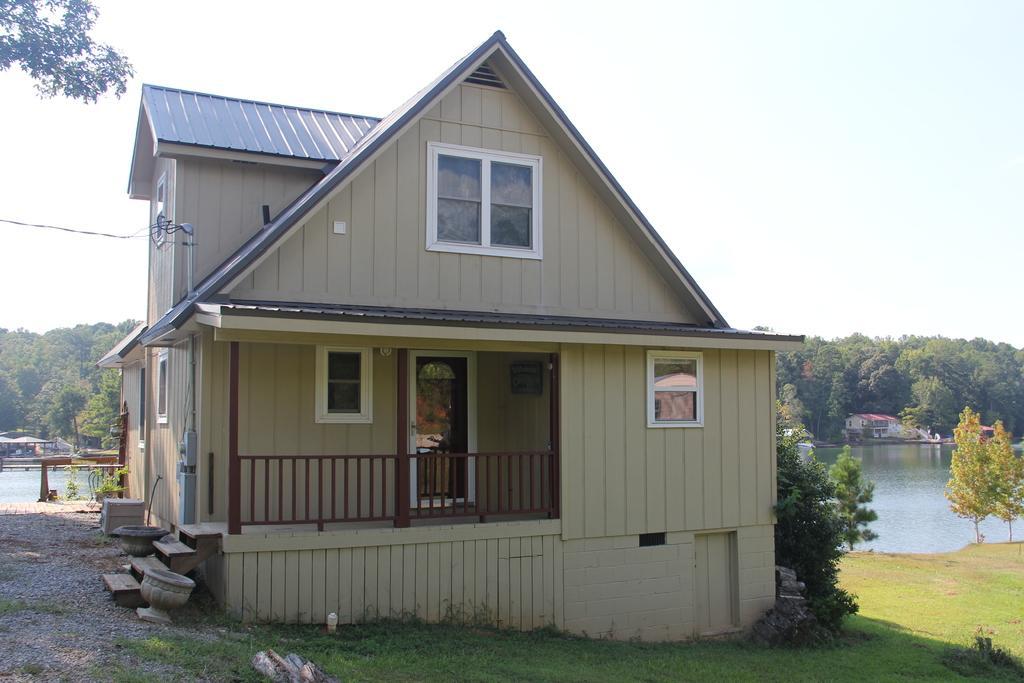How would you summarize this image in a sentence or two? In this image there are houses, trees, water, grass, cables, a shed, stones and the sky. 